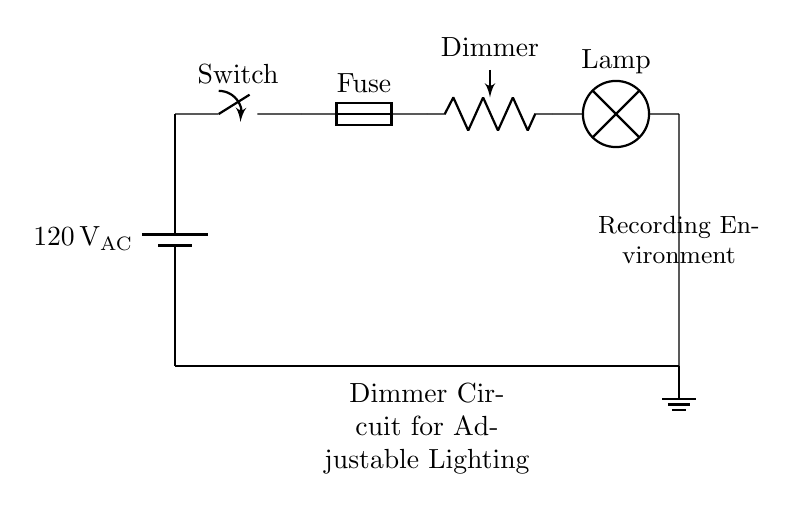What is the voltage of this circuit? The voltage is 120 Volts, as indicated by the power source labeled with 120V AC.
Answer: 120 Volts What component is used for dimming the light? The component used for dimming the light is the potentiometer, labeled as Dimmer in the circuit.
Answer: Dimmer Which component provides protection from overload? The component providing protection from overload is the fuse, which is labeled as Fuse in the circuit.
Answer: Fuse How many main components are there in the circuit? There are five main components in the circuit: battery, switch, fuse, dimmer, and lamp.
Answer: Five What is the purpose of the switch in this circuit? The switch is used to control the power flow to the circuit, allowing the user to turn the lamp on or off.
Answer: Control power flow Does this circuit show AC or DC voltage? This circuit shows AC voltage, as indicated by the AC label on the battery.
Answer: AC How does the dimmer affect the lamp's brightness? The dimmer reduces the voltage supplied to the lamp, which alters its brightness by varying the electrical current flowing through it.
Answer: Varies brightness 